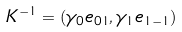<formula> <loc_0><loc_0><loc_500><loc_500>K ^ { - 1 } = ( \gamma _ { 0 } e _ { 0 1 } , \gamma _ { 1 } e _ { 1 - 1 } )</formula> 